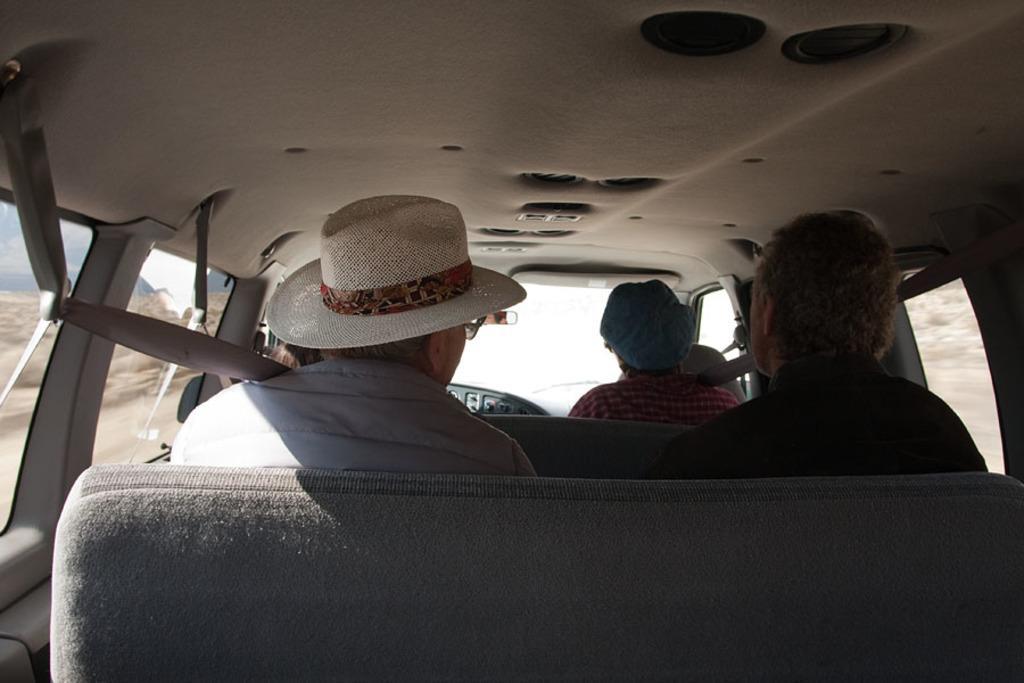Can you describe this image briefly? Here in this picture we can see a group of people sitting in a car, travelling over a place and the man on the left side is wearing a hat and through the windows we can see plants present on the ground. 